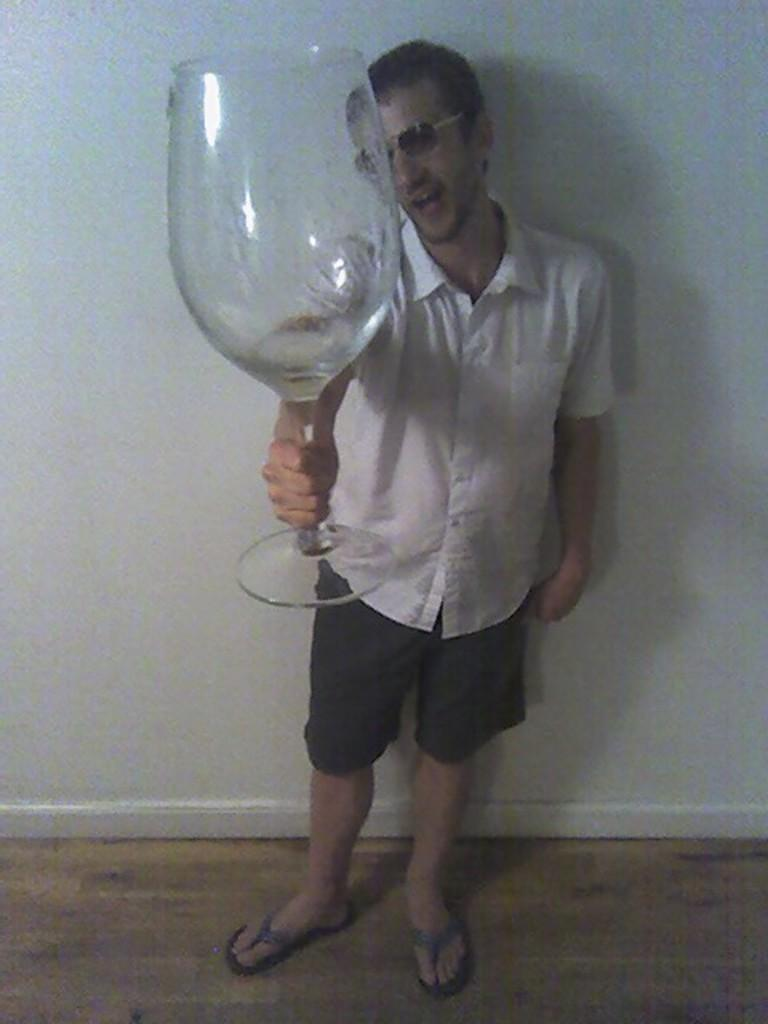What is the main subject of the image? There is a person standing in the center of the image. What is the person holding in the image? The person is holding a glass tumbler. What can be seen in the background of the image? There is a wall in the background of the image. How many cattle are visible in the image? There are no cattle present in the image. What type of clock is hanging on the wall in the image? There is no clock visible in the image; only a wall is present in the background. 